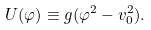Convert formula to latex. <formula><loc_0><loc_0><loc_500><loc_500>U ( \varphi ) \equiv g ( \varphi ^ { 2 } - v ^ { 2 } _ { 0 } ) .</formula> 